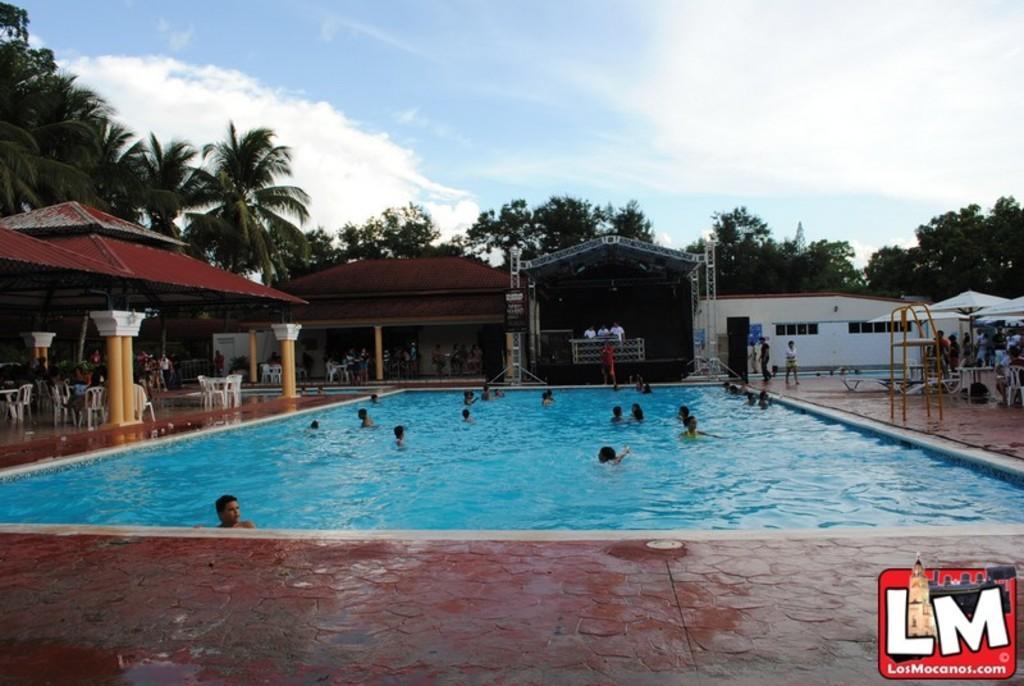How would you summarize this image in a sentence or two? This picture is clicked outside. In the center we can see the group of persons in the swimming pool and we can see the chairs, table and a ladder and many other objects and we can see the group of persons standing under the tents. In the background we can see the sky and the trees. At the bottom right corner there is a watermark on the image. 